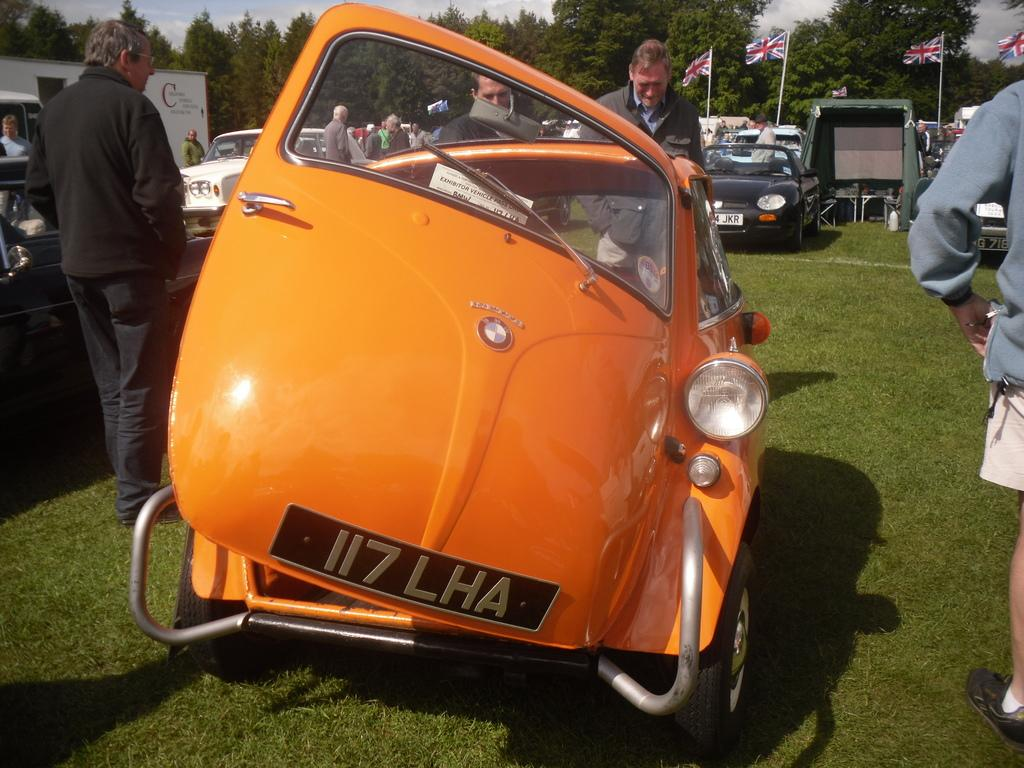What is happening in the image? There are persons standing in the image. What is unusual about the location of the vehicles in the image? Vehicles are present on the grass. Can you describe the background of the image? There are people, flags with sticks, trees, and the sky visible in the background. What type of cover is being used to protect the vehicles from the flight of the birds in the image? There is no mention of birds or the need for protection in the image, so there is no cover present. 